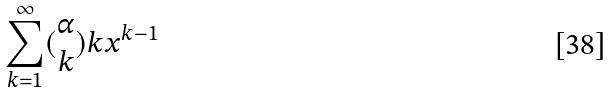<formula> <loc_0><loc_0><loc_500><loc_500>\sum _ { k = 1 } ^ { \infty } ( \begin{matrix} \alpha \\ k \end{matrix} ) k x ^ { k - 1 }</formula> 